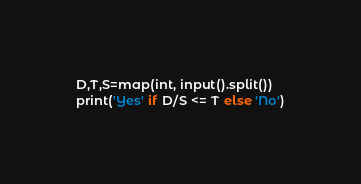Convert code to text. <code><loc_0><loc_0><loc_500><loc_500><_Python_>D,T,S=map(int, input().split())
print('Yes' if D/S <= T else 'No')</code> 